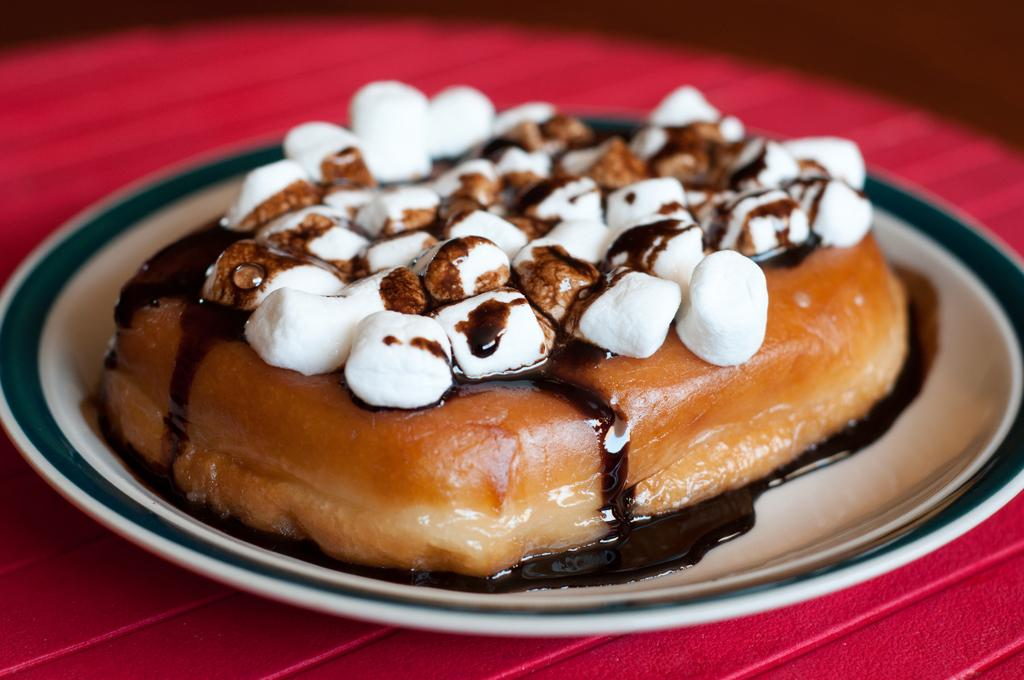What is in the plate that is visible in the image? There is a bread pudding in a plate. Where is the plate located in the image? The plate is on a table. Can you describe the setting where the plate is located? The image may have been taken in a room, but the specific location is not clear. How does the bread pudding show respect to the environment in the image? The bread pudding does not show respect to the environment in the image, as it is a dessert and not a living being or entity capable of demonstrating respect. 